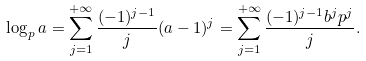Convert formula to latex. <formula><loc_0><loc_0><loc_500><loc_500>\log _ { p } a = \sum _ { j = 1 } ^ { + \infty } \frac { ( - 1 ) ^ { j - 1 } } { j } ( a - 1 ) ^ { j } = \sum _ { j = 1 } ^ { + \infty } \frac { ( - 1 ) ^ { j - 1 } b ^ { j } p ^ { j } } { j } .</formula> 